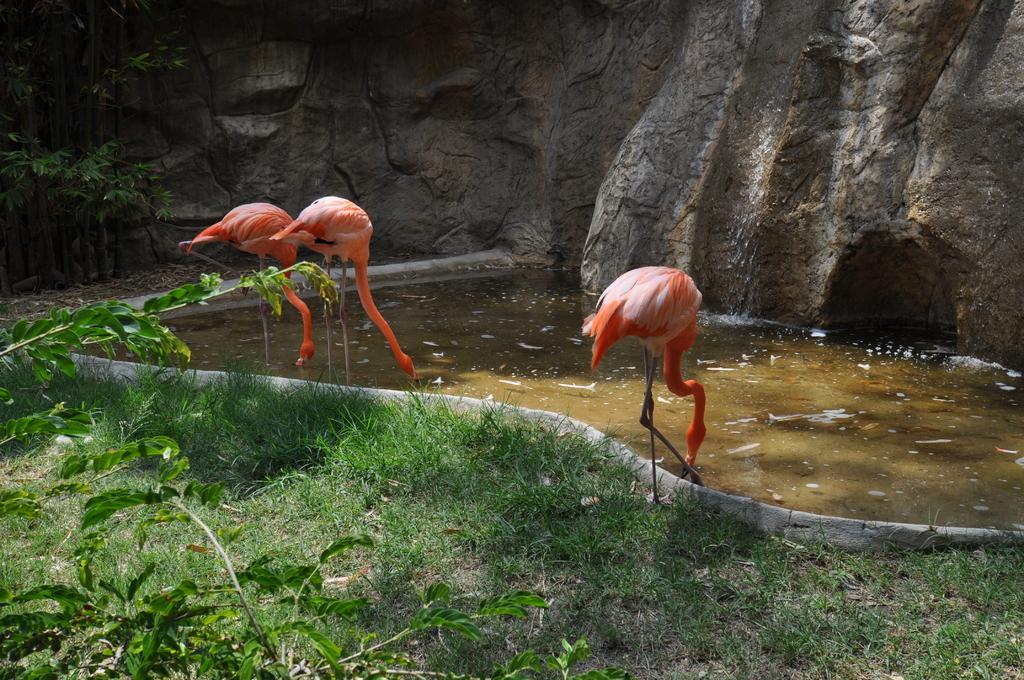Please provide a concise description of this image. As we can see in the image there is grass, hill, water and orange color cranes. 